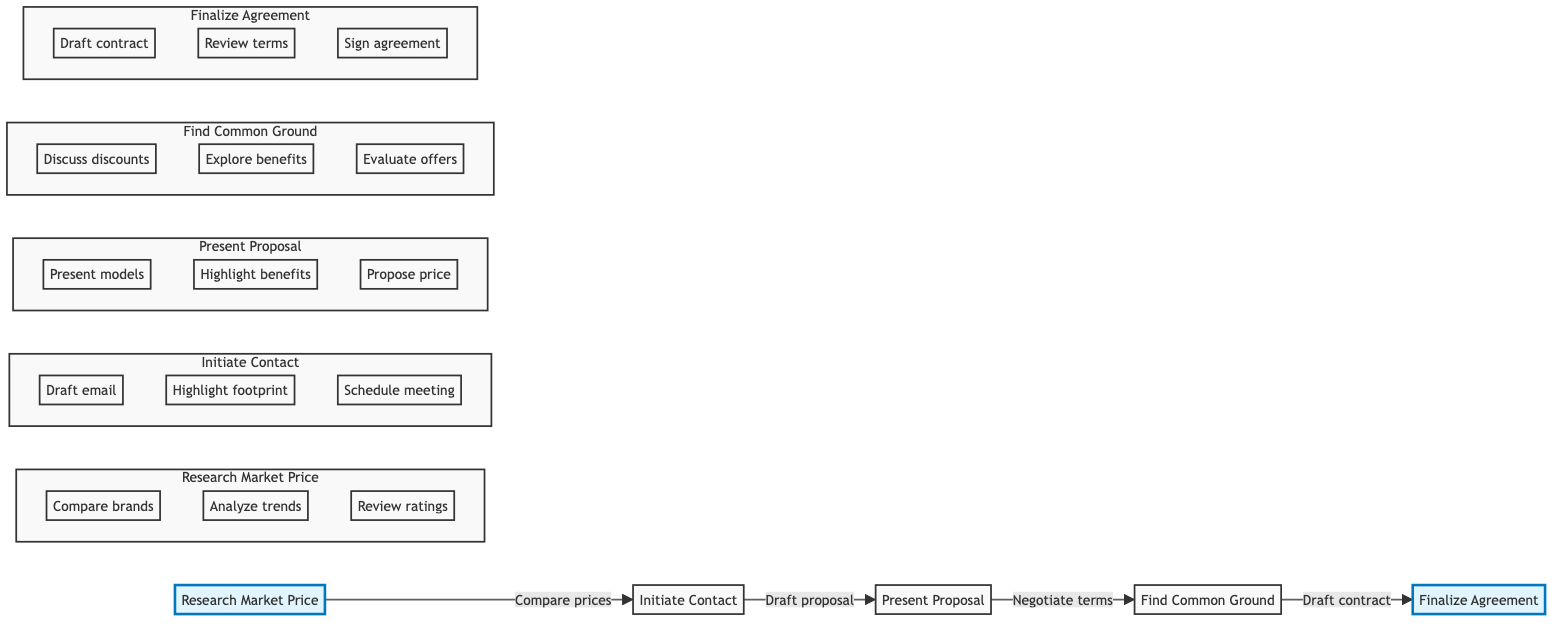What is the first stage in the negotiation process? The first stage, as indicated in the diagram, is "Research Market Price." It is the starting point from which all subsequent actions flow.
Answer: Research Market Price What do you present after initiating contact? After the "Initiate Contact" stage, the next step is to "Present Proposal." It outlines the offer being made to the supplier following the initial communication.
Answer: Present Proposal How many action items are listed under "Find Common Ground"? The "Find Common Ground" stage lists three distinct action items that focus on negotiating terms and discussing potential benefits.
Answer: 3 Which two stages are highlighted in the diagram? The stages "Research Market Price" and "Finalize Agreement" are highlighted, indicating their importance in the overall flow of the negotiation process.
Answer: Research Market Price, Finalize Agreement What is the last action taken in the negotiation flow? The final action taken in the flow is "Sign agreement," which occurs during the "Finalize Agreement" stage, confirming the deal reached with the supplier.
Answer: Sign agreement What is the relationship between "Present Proposal" and "Find Common Ground"? The relationship is sequential: "Present Proposal" leads directly to "Find Common Ground," indicating that negotiation follows the proposal presentation in the process.
Answer: Sequential relationship What stage requires evaluating counteroffers? "Find Common Ground" is the stage that requires evaluating counteroffers as part of the negotiation process, facilitating adjustments as needed.
Answer: Find Common Ground How many total stages are in the diagram? There are five total stages depicted in the flowchart, outlining the complete negotiation process with suppliers.
Answer: 5 What action is associated with scheduling a meeting? The action associated with scheduling a meeting is found in the "Initiate Contact" stage, where it is crucial to establish communication with suppliers.
Answer: Schedule meeting 